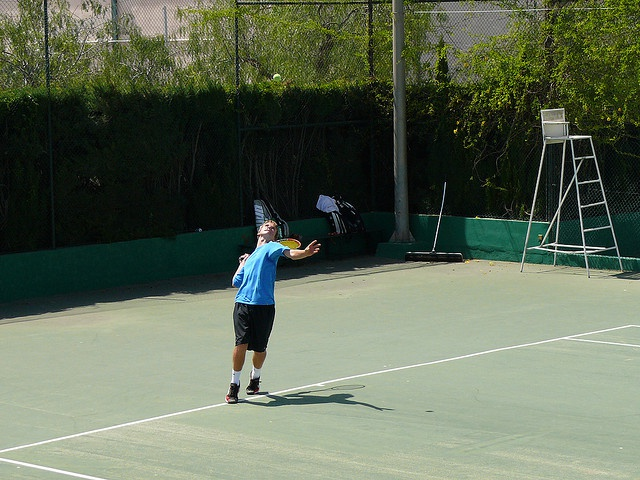Describe the objects in this image and their specific colors. I can see chair in gray, black, darkgray, and lightgray tones, people in gray, black, blue, and lightblue tones, backpack in gray, black, and blue tones, tennis racket in gray, olive, and maroon tones, and sports ball in gray, green, olive, and lightyellow tones in this image. 